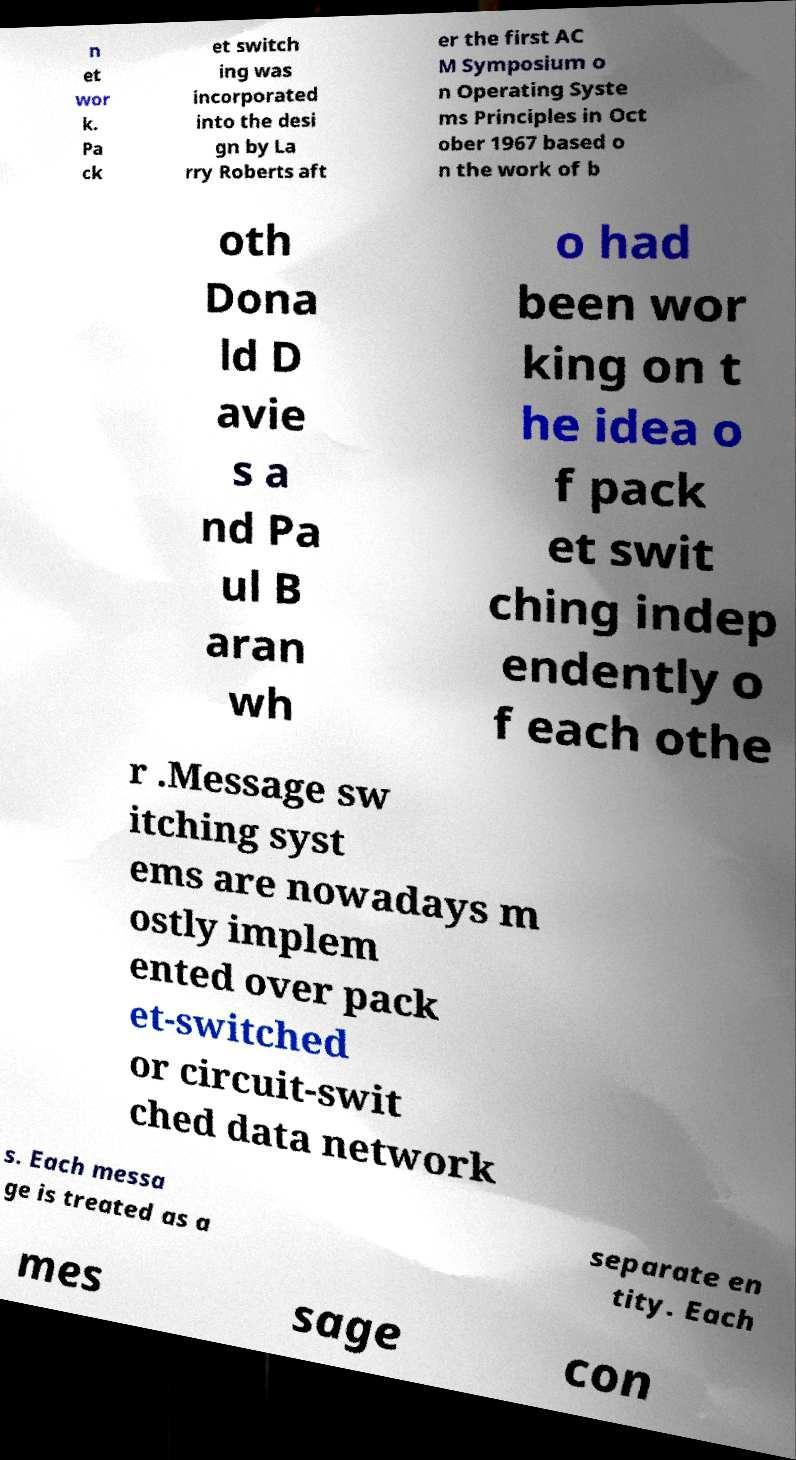Can you accurately transcribe the text from the provided image for me? n et wor k. Pa ck et switch ing was incorporated into the desi gn by La rry Roberts aft er the first AC M Symposium o n Operating Syste ms Principles in Oct ober 1967 based o n the work of b oth Dona ld D avie s a nd Pa ul B aran wh o had been wor king on t he idea o f pack et swit ching indep endently o f each othe r .Message sw itching syst ems are nowadays m ostly implem ented over pack et-switched or circuit-swit ched data network s. Each messa ge is treated as a separate en tity. Each mes sage con 